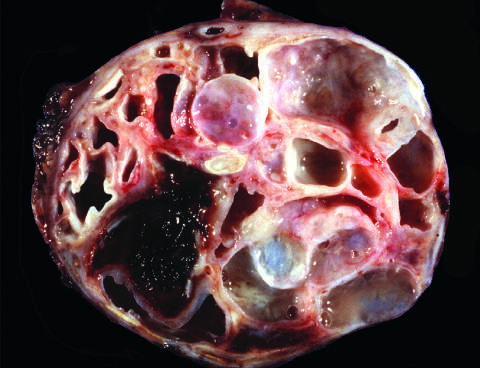re the cysts large and filled with tenacious mucin?
Answer the question using a single word or phrase. Yes 